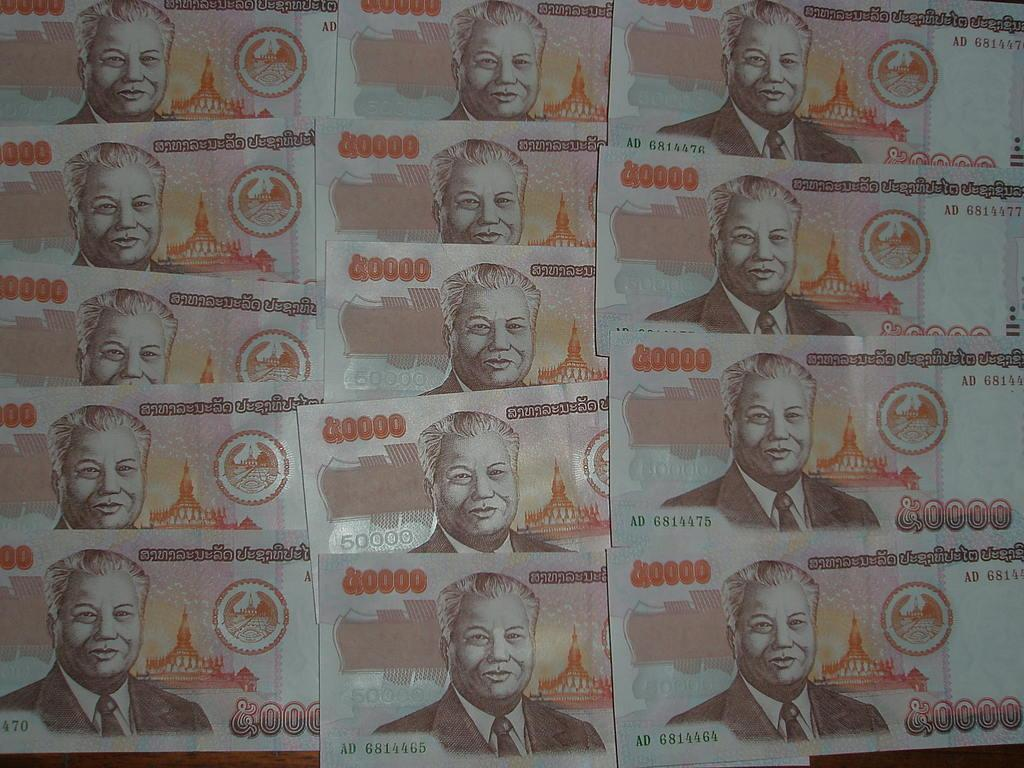What type of objects are present in the image? There are currency notes in the image. What can be seen on the currency notes? The currency notes have depictions of a man. Are there any words or symbols on the currency notes? Yes, there is writing on the currency notes. What type of leaf is growing on the tent in the image? There is no tent or leaf present in the image; it only contains currency notes with depictions of a man and writing. 